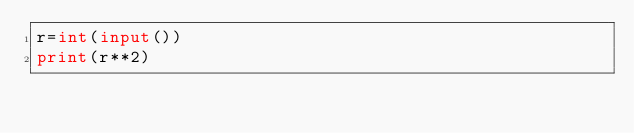<code> <loc_0><loc_0><loc_500><loc_500><_Python_>r=int(input())
print(r**2)</code> 